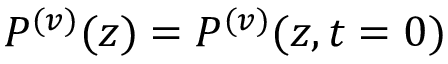Convert formula to latex. <formula><loc_0><loc_0><loc_500><loc_500>P ^ { ( v ) } ( z ) = P ^ { ( v ) } ( z , t = 0 )</formula> 